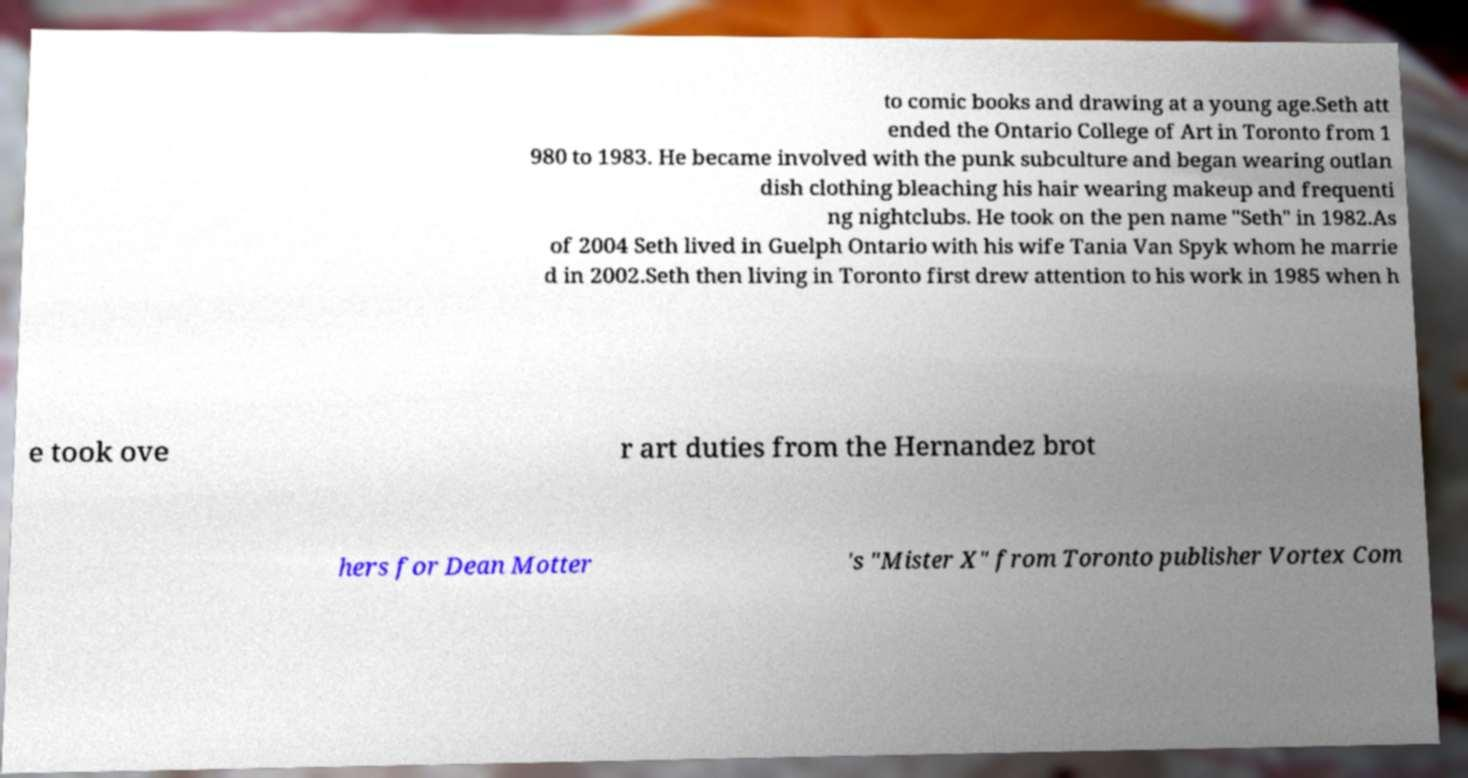Please read and relay the text visible in this image. What does it say? to comic books and drawing at a young age.Seth att ended the Ontario College of Art in Toronto from 1 980 to 1983. He became involved with the punk subculture and began wearing outlan dish clothing bleaching his hair wearing makeup and frequenti ng nightclubs. He took on the pen name "Seth" in 1982.As of 2004 Seth lived in Guelph Ontario with his wife Tania Van Spyk whom he marrie d in 2002.Seth then living in Toronto first drew attention to his work in 1985 when h e took ove r art duties from the Hernandez brot hers for Dean Motter 's "Mister X" from Toronto publisher Vortex Com 